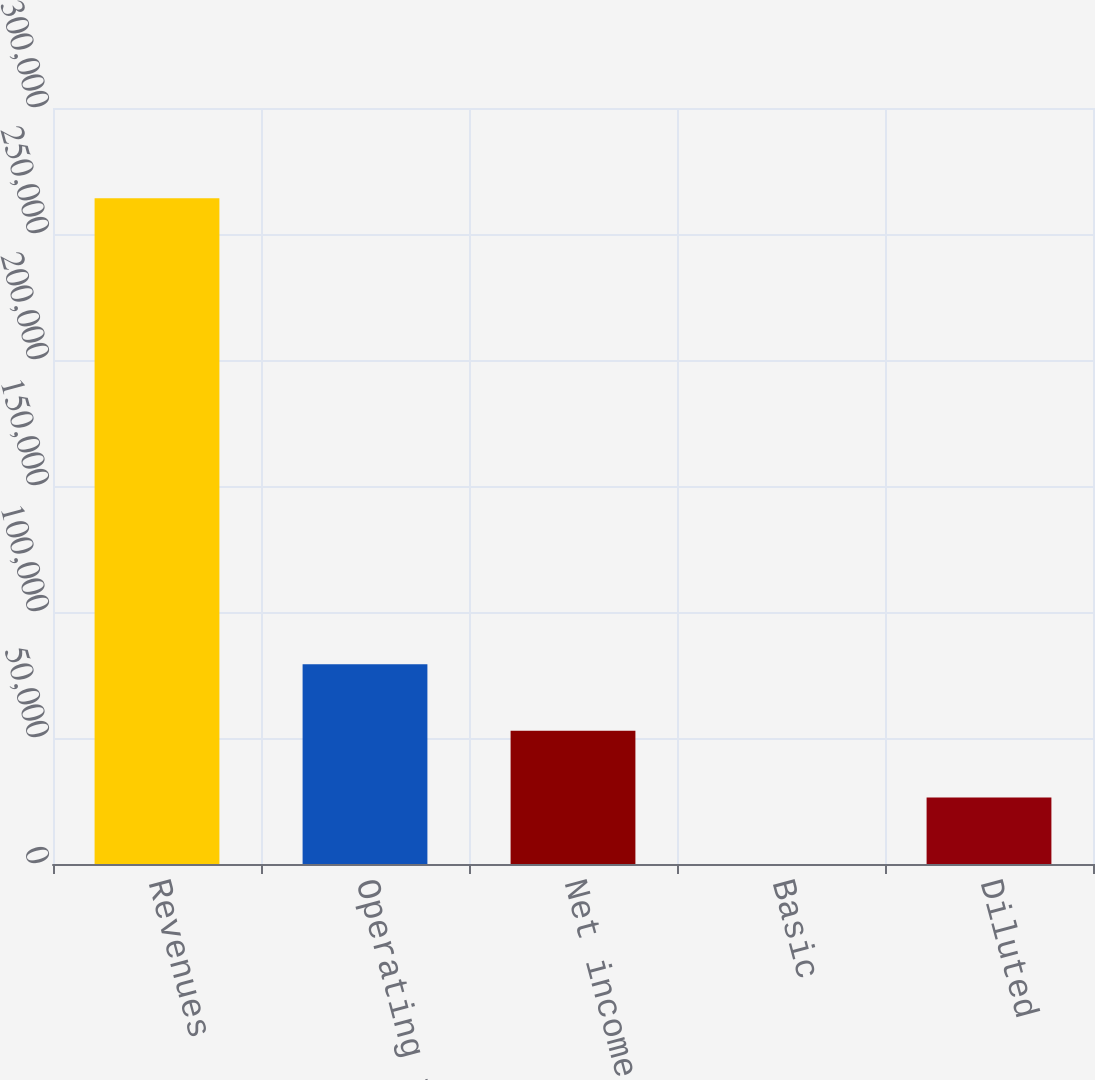Convert chart to OTSL. <chart><loc_0><loc_0><loc_500><loc_500><bar_chart><fcel>Revenues<fcel>Operating income (1)<fcel>Net income<fcel>Basic<fcel>Diluted<nl><fcel>264197<fcel>79259.1<fcel>52839.5<fcel>0.08<fcel>26419.8<nl></chart> 